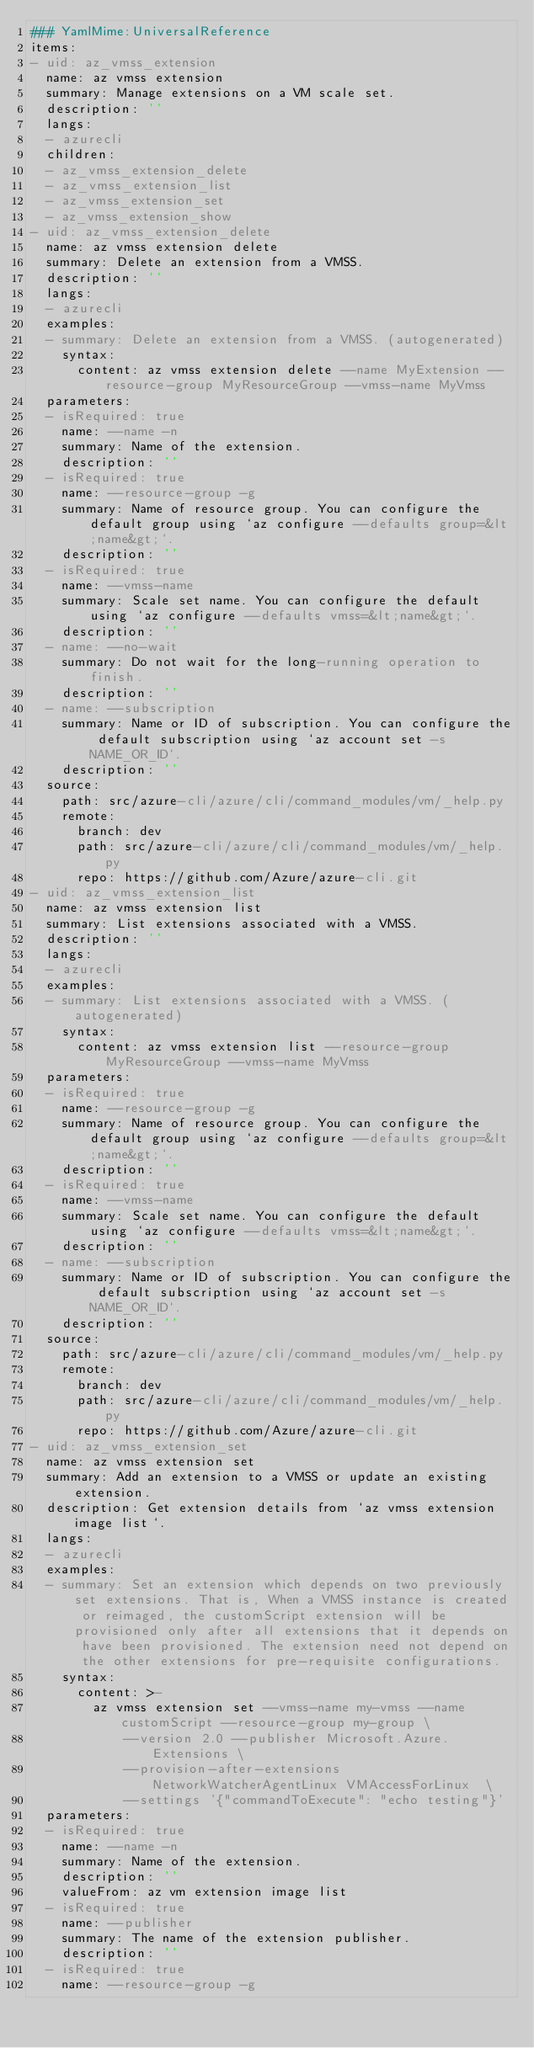<code> <loc_0><loc_0><loc_500><loc_500><_YAML_>### YamlMime:UniversalReference
items:
- uid: az_vmss_extension
  name: az vmss extension
  summary: Manage extensions on a VM scale set.
  description: ''
  langs:
  - azurecli
  children:
  - az_vmss_extension_delete
  - az_vmss_extension_list
  - az_vmss_extension_set
  - az_vmss_extension_show
- uid: az_vmss_extension_delete
  name: az vmss extension delete
  summary: Delete an extension from a VMSS.
  description: ''
  langs:
  - azurecli
  examples:
  - summary: Delete an extension from a VMSS. (autogenerated)
    syntax:
      content: az vmss extension delete --name MyExtension --resource-group MyResourceGroup --vmss-name MyVmss
  parameters:
  - isRequired: true
    name: --name -n
    summary: Name of the extension.
    description: ''
  - isRequired: true
    name: --resource-group -g
    summary: Name of resource group. You can configure the default group using `az configure --defaults group=&lt;name&gt;`.
    description: ''
  - isRequired: true
    name: --vmss-name
    summary: Scale set name. You can configure the default using `az configure --defaults vmss=&lt;name&gt;`.
    description: ''
  - name: --no-wait
    summary: Do not wait for the long-running operation to finish.
    description: ''
  - name: --subscription
    summary: Name or ID of subscription. You can configure the default subscription using `az account set -s NAME_OR_ID`.
    description: ''
  source:
    path: src/azure-cli/azure/cli/command_modules/vm/_help.py
    remote:
      branch: dev
      path: src/azure-cli/azure/cli/command_modules/vm/_help.py
      repo: https://github.com/Azure/azure-cli.git
- uid: az_vmss_extension_list
  name: az vmss extension list
  summary: List extensions associated with a VMSS.
  description: ''
  langs:
  - azurecli
  examples:
  - summary: List extensions associated with a VMSS. (autogenerated)
    syntax:
      content: az vmss extension list --resource-group MyResourceGroup --vmss-name MyVmss
  parameters:
  - isRequired: true
    name: --resource-group -g
    summary: Name of resource group. You can configure the default group using `az configure --defaults group=&lt;name&gt;`.
    description: ''
  - isRequired: true
    name: --vmss-name
    summary: Scale set name. You can configure the default using `az configure --defaults vmss=&lt;name&gt;`.
    description: ''
  - name: --subscription
    summary: Name or ID of subscription. You can configure the default subscription using `az account set -s NAME_OR_ID`.
    description: ''
  source:
    path: src/azure-cli/azure/cli/command_modules/vm/_help.py
    remote:
      branch: dev
      path: src/azure-cli/azure/cli/command_modules/vm/_help.py
      repo: https://github.com/Azure/azure-cli.git
- uid: az_vmss_extension_set
  name: az vmss extension set
  summary: Add an extension to a VMSS or update an existing extension.
  description: Get extension details from `az vmss extension image list`.
  langs:
  - azurecli
  examples:
  - summary: Set an extension which depends on two previously set extensions. That is, When a VMSS instance is created or reimaged, the customScript extension will be provisioned only after all extensions that it depends on have been provisioned. The extension need not depend on the other extensions for pre-requisite configurations.
    syntax:
      content: >-
        az vmss extension set --vmss-name my-vmss --name customScript --resource-group my-group \
            --version 2.0 --publisher Microsoft.Azure.Extensions \
            --provision-after-extensions NetworkWatcherAgentLinux VMAccessForLinux  \
            --settings '{"commandToExecute": "echo testing"}'
  parameters:
  - isRequired: true
    name: --name -n
    summary: Name of the extension.
    description: ''
    valueFrom: az vm extension image list
  - isRequired: true
    name: --publisher
    summary: The name of the extension publisher.
    description: ''
  - isRequired: true
    name: --resource-group -g</code> 